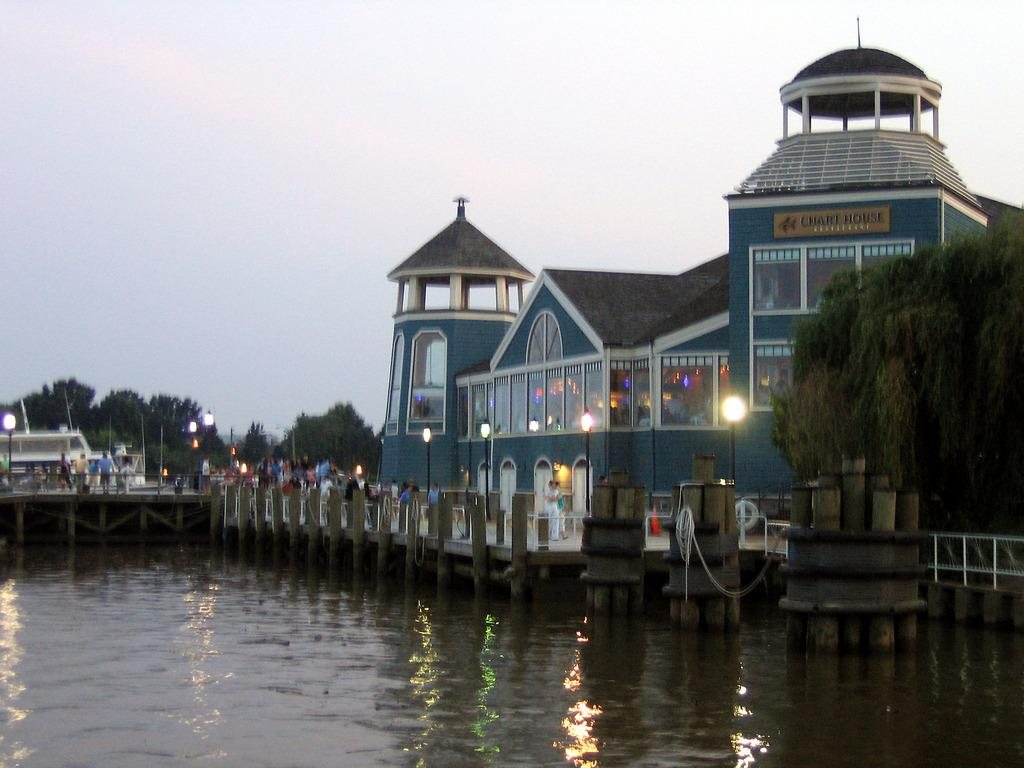<image>
Offer a succinct explanation of the picture presented. A Chart House Restaurant sitting on a waterfront pier with a boat in the background. 